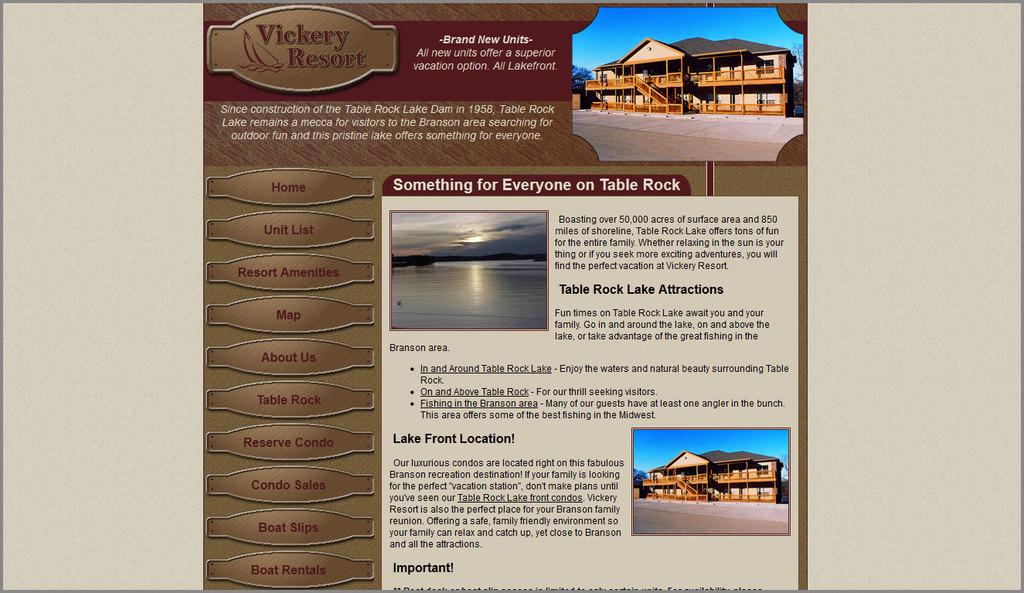<image>
Relay a brief, clear account of the picture shown. a page on a website that says Lake Front Location 